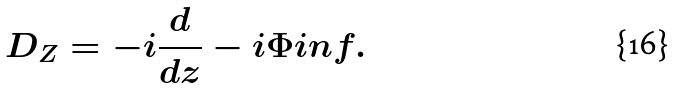Convert formula to latex. <formula><loc_0><loc_0><loc_500><loc_500>D _ { Z } = - i \frac { d } { d z } - i \Phi i n f .</formula> 